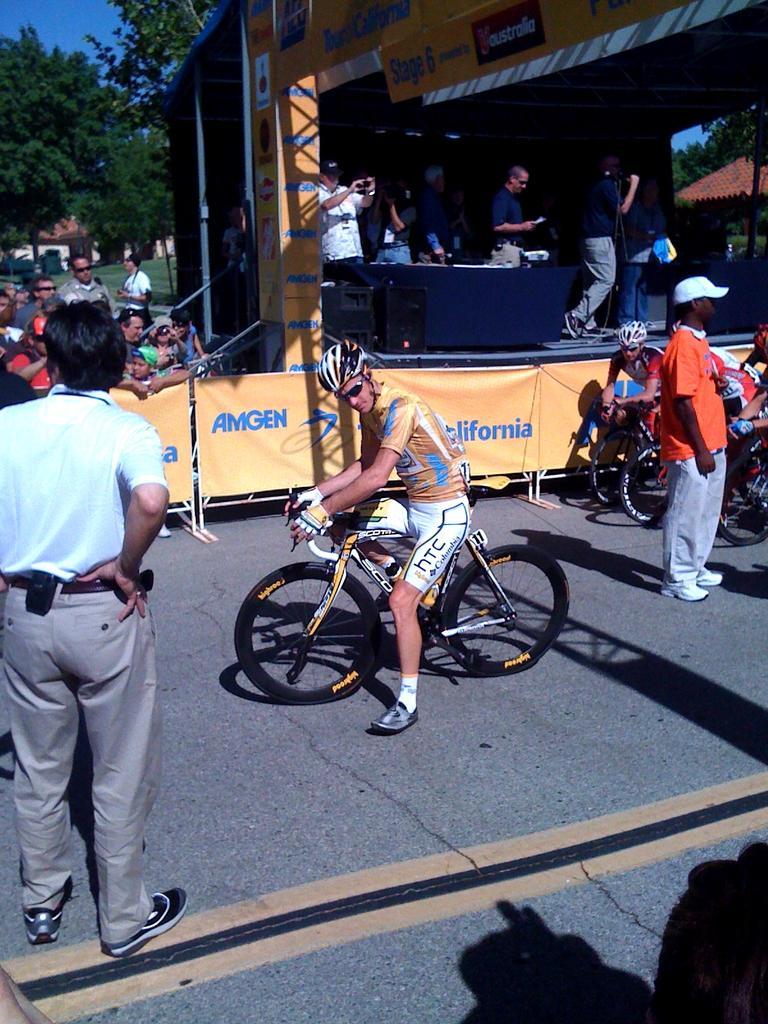Could you give a brief overview of what you see in this image? This is a picture taken in the outdoors. It is sunny. The man in yellow t shirt was riding a bicycle. Background of the man there are banners and group of people, trees and sky. 